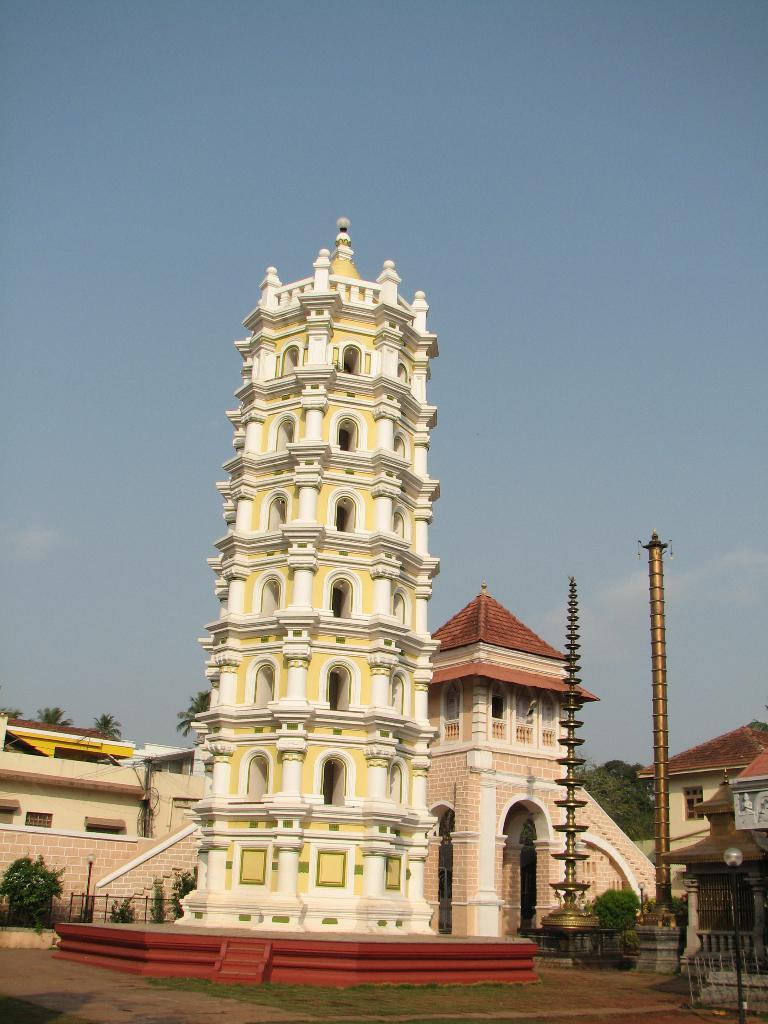What type of vegetation is present in the image? There are trees in the image. What type of structures can be seen in the image? There are buildings in the image. What are the two metal objects in the image? There are two metal poles in the image. What other type of plant life is present in the image? There are bushes in the image. How many rabbits are hopping around the metal poles in the image? There are no rabbits present in the image. What type of power source is connected to the metal poles in the image? There is no power source connected to the metal poles in the image. 